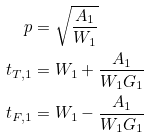<formula> <loc_0><loc_0><loc_500><loc_500>p & = \sqrt { \frac { A _ { 1 } } { W _ { 1 } } } \\ t _ { T , 1 } & = W _ { 1 } + \frac { A _ { 1 } } { W _ { 1 } G _ { 1 } } \\ t _ { F , 1 } & = W _ { 1 } - \frac { A _ { 1 } } { W _ { 1 } G _ { 1 } }</formula> 